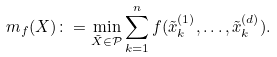Convert formula to latex. <formula><loc_0><loc_0><loc_500><loc_500>m _ { f } ( X ) \colon = \min _ { \tilde { X } \in \mathcal { P } } \sum _ { k = 1 } ^ { n } f ( \tilde { x } ^ { ( 1 ) } _ { k } , \dots , \tilde { x } ^ { ( d ) } _ { k } ) .</formula> 